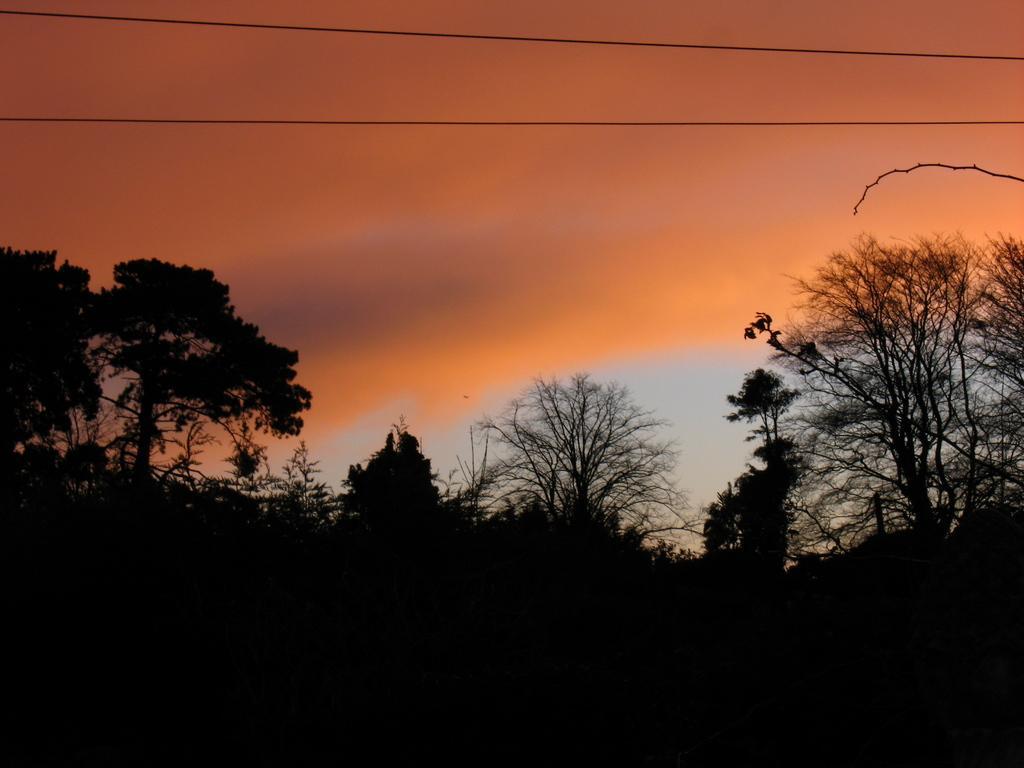Can you describe this image briefly? In this image we can see many trees. There are few electrical cables at the top of the image. There are few clouds in the sky. 